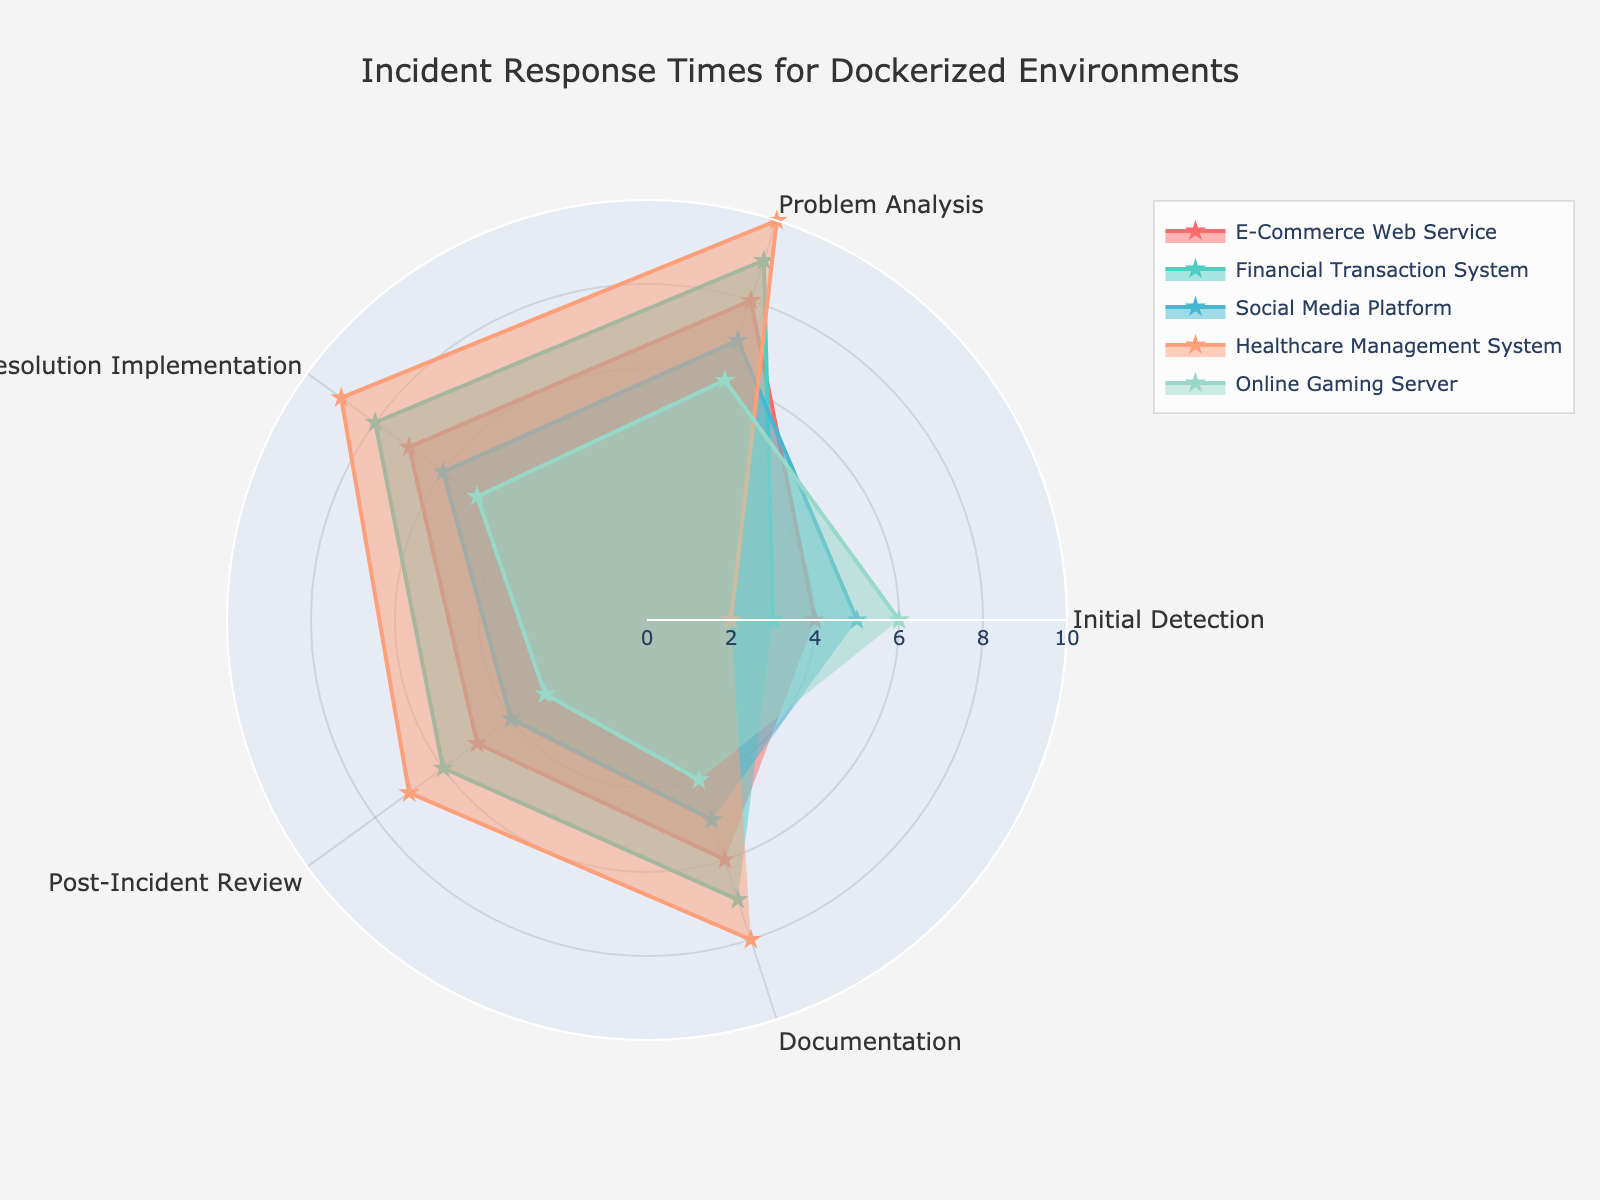What's the title of the radar chart? The title is typically found at the top of the chart and summarizes the content of the chart. In this case, it's 'Incident Response Times for Dockerized Environments'.
Answer: 'Incident Response Times for Dockerized Environments' How many categories are displayed in the radar chart? By looking at the data, we can see there are five categories: Initial Detection, Problem Analysis, Resolution Implementation, Post-Incident Review, and Documentation. Observing the radar chart, we can count the distinct categories represented around the radial axis.
Answer: 5 Which environment has the highest value in Documentation? Referring to the radial axis labeled 'Documentation' and checking which dataset has the highest point on this axis, we can observe that the Healthcare Management System has the highest value.
Answer: Healthcare Management System Which two environments have identical values for Problem Analysis? By comparing the values along the 'Problem Analysis' axis, we can see that the E-Commerce Web Service and Online Gaming Server both have a value of 6. This can be confirmed by checking these points in the radar chart.
Answer: E-Commerce Web Service and Online Gaming Server How does the value for Initial Detection in Online Gaming Server compare to that in Healthcare Management System? By comparing the values in the 'Initial Detection' category for both Online Gaming Server and Healthcare Management System, we observe that Online Gaming Server has a higher value (6) compared to Healthcare Management System (2).
Answer: Online Gaming Server has a higher value What is the average value of Resolution Implementation across all environments? To find the average, sum up the Resolution Implementation values (7+8+6+9+5) which equals 35. Then divide by the number of environments (5), resulting in an average of 7.
Answer: 7 Which environment shows the most balance across all five categories? A balanced environment would show similar values across all categories, forming a more regular and symmetric shape in the radar chart. Comparing the shapes, the E-Commerce Web Service appears to have the most balanced response times with values not varying drastically.
Answer: E-Commerce Web Service What is the difference in Post-Incident Review between Social Media Platform and Financial Transaction System? The value for Post-Incident Review in Social Media Platform is 4 and in Financial Transaction System is 6. The difference is calculated as 6 - 4 = 2.
Answer: 2 Which category shows the most significant variation across all environments? By visually comparing the spread of values for each category, Problem Analysis displays values ranging from 6 to 10, indicating a significant variation.
Answer: Problem Analysis How does the value for Post-Incident Review in E-Commerce Web Service compare to the average value for Documentation across all environments? For Documentation, we first find the average: (6+7+5+8+4)/5 = 6. The Post-Incident Review value for E-Commerce Web Service is 5. Comparing these, the value for E-Commerce Web Service in Post-Incident Review is less than the average Documentation value.
Answer: Less 